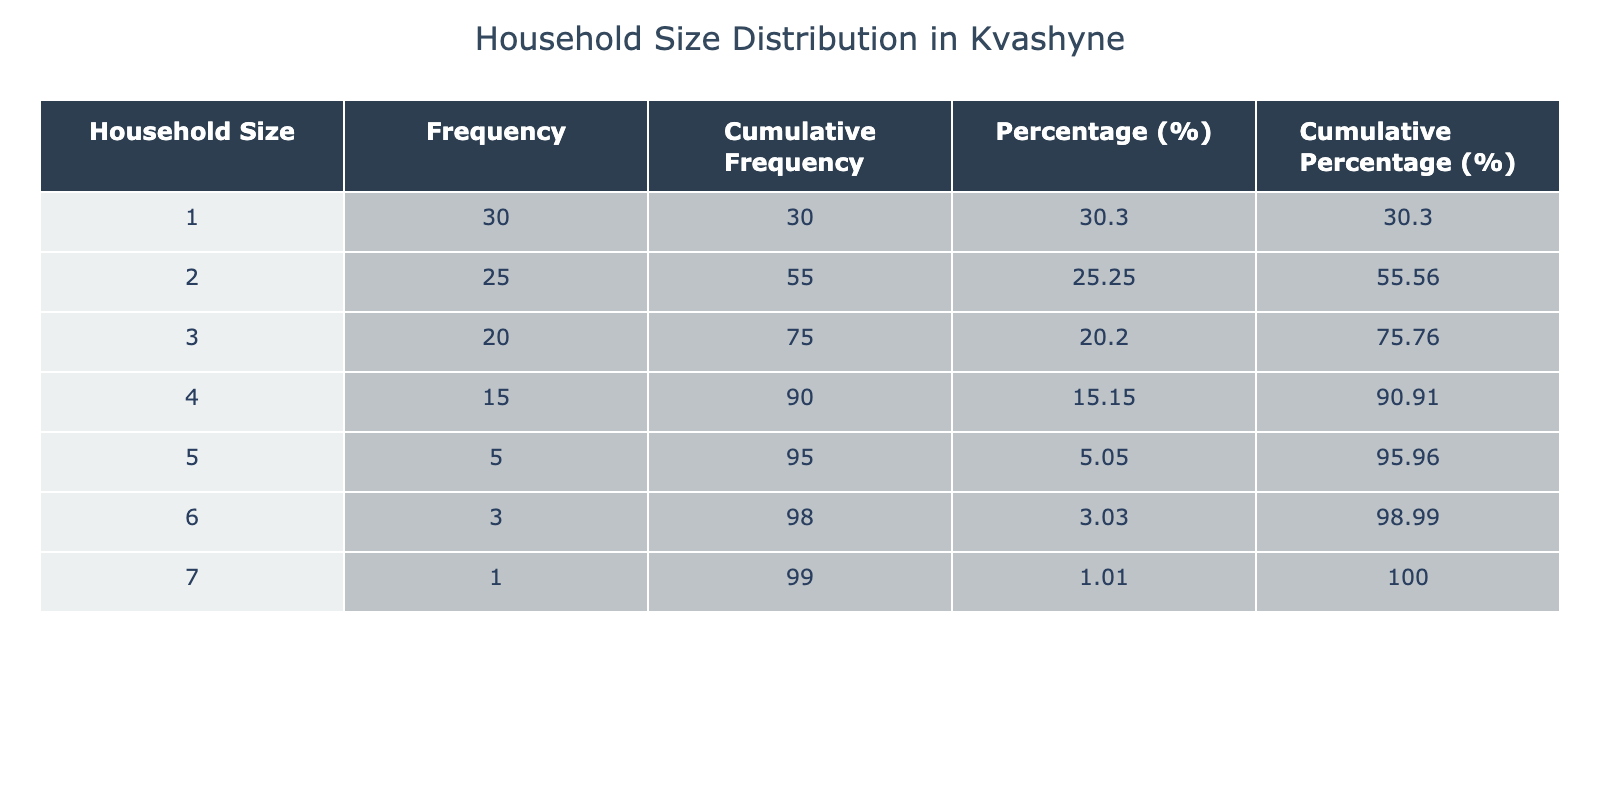What is the frequency of households with three members? The table shows the frequency of household sizes. Looking under the Household Size column for "3," the Frequency column indicates that there are 20 households with three members.
Answer: 20 How many households have at least five members? To find this, we look for household sizes of 5, 6, and 7. Adding their frequencies: 5 (for size 5) + 3 (for size 6) + 1 (for size 7) = 9 households have at least five members.
Answer: 9 What is the cumulative frequency for households with two members? The cumulative frequency for any size is the sum of all frequencies up to and including that size. For size 2, we add the frequencies of sizes 1 and 2: 30 (size 1) + 25 (size 2) = 55.
Answer: 55 Is the percentage of households with one member greater than those with six members? The percentage for one-member households is (30/100) * 100 = 30%, while for six-member households it's (3/100) * 100 = 3%. Since 30% is greater than 3%, the statement is true.
Answer: Yes What is the average household size based on the data provided? To calculate the average, we first find the total number of members: (1*30) + (2*25) + (3*20) + (4*15) + (5*5) + (6*3) + (7*1) = 30 + 50 + 60 + 60 + 25 + 18 + 7 = 250. The total number of households is 30 + 25 + 20 + 15 + 5 + 3 + 1 = 99. Therefore, the average household size = 250 / 99 ≈ 2.53.
Answer: 2.53 How many more households are there with one member compared to those with seven members? From the table, there are 30 households with one member and 1 household with seven members. To find the difference, subtract the number of seven-member households from the number of one-member households: 30 - 1 = 29.
Answer: 29 